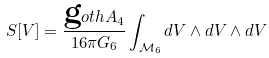<formula> <loc_0><loc_0><loc_500><loc_500>S [ V ] = \frac { \text  goth{A} _ { 4 } } { 1 6 \pi G _ { 6 } } \int _ { \mathcal { M } _ { 6 } } d V \wedge d V \wedge d V</formula> 